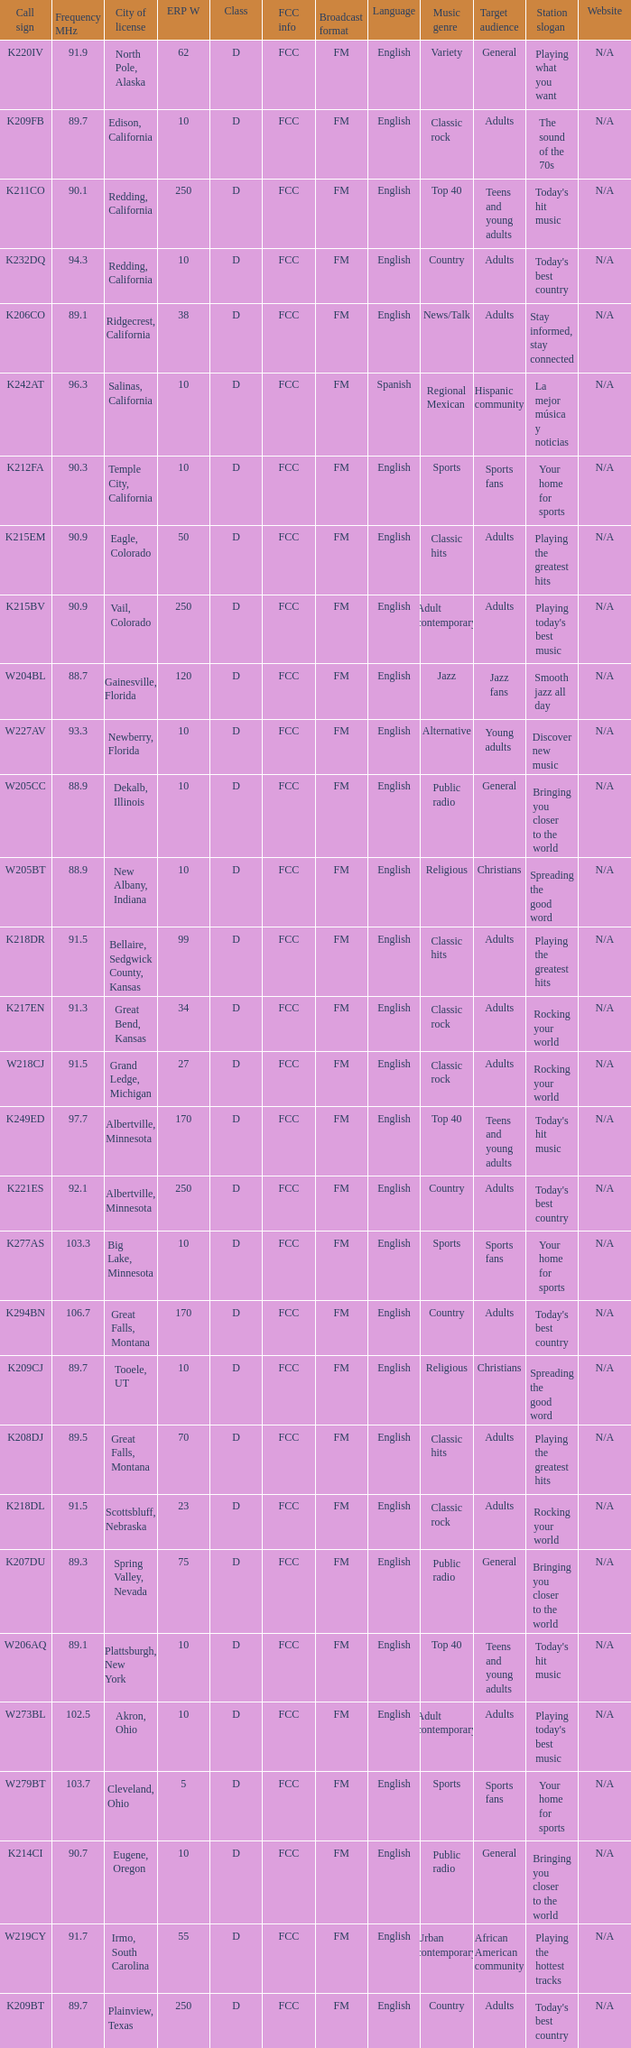What is the call sign of the translator in Spring Valley, Nevada? K207DU. 